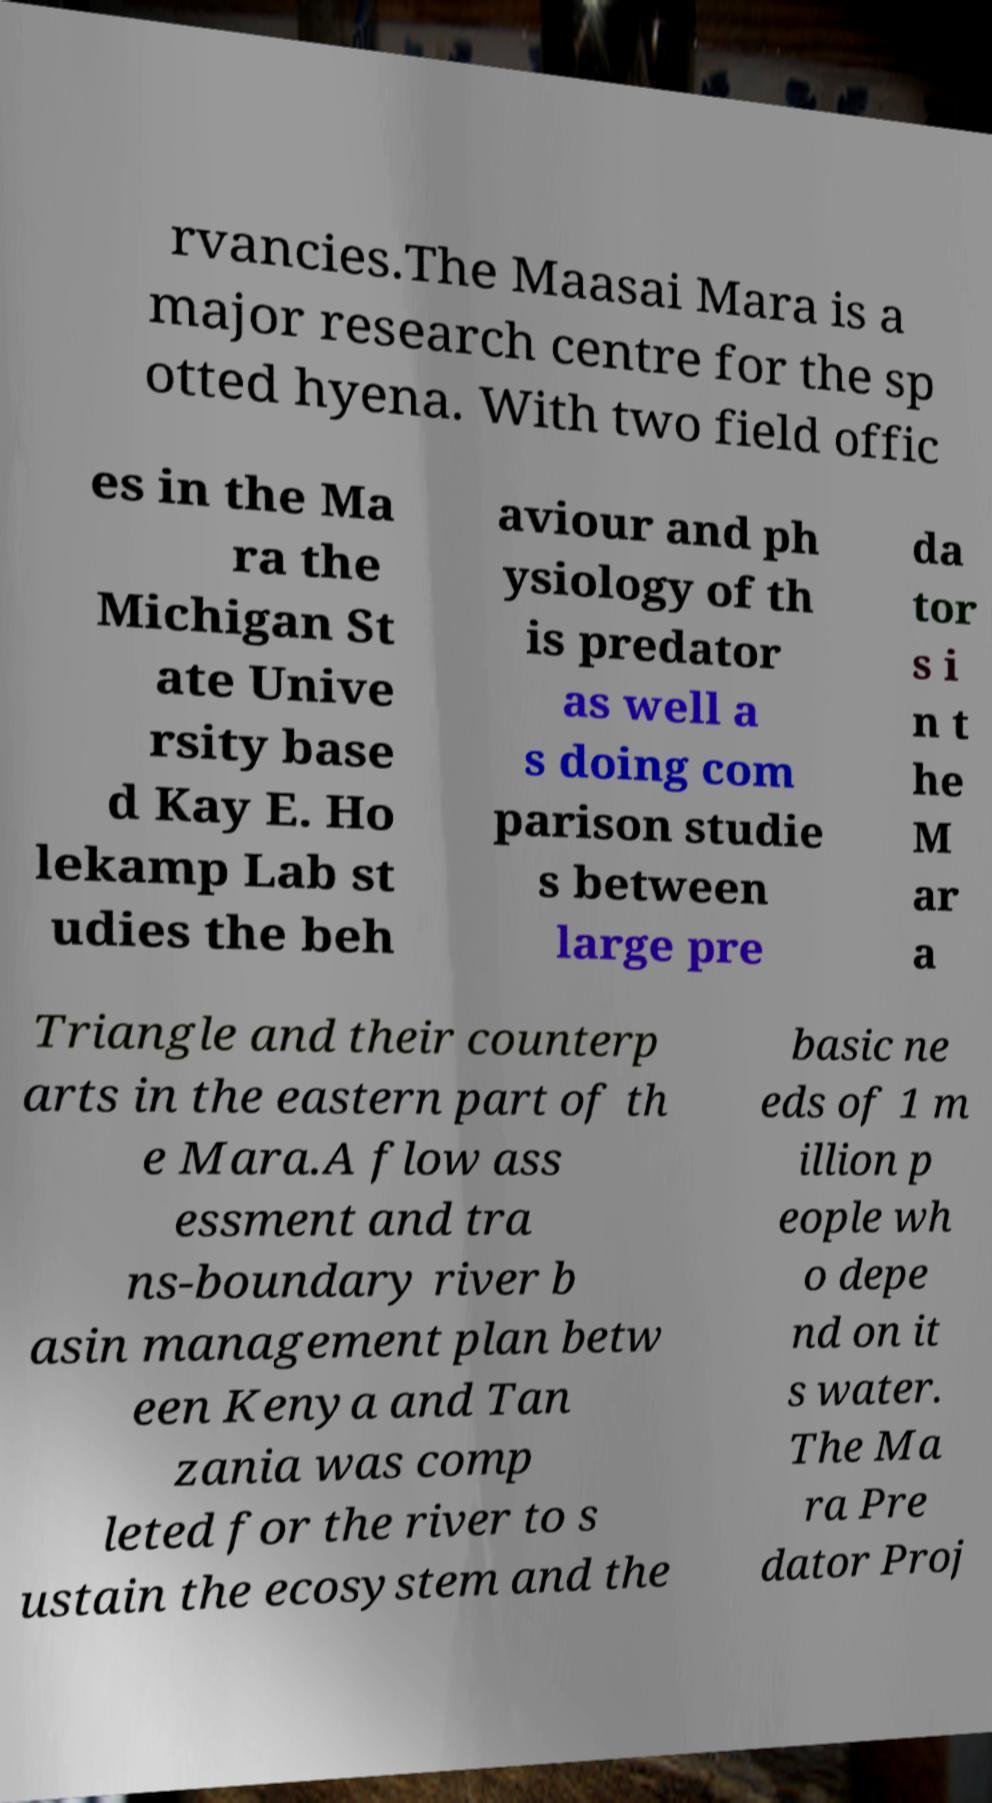Please identify and transcribe the text found in this image. rvancies.The Maasai Mara is a major research centre for the sp otted hyena. With two field offic es in the Ma ra the Michigan St ate Unive rsity base d Kay E. Ho lekamp Lab st udies the beh aviour and ph ysiology of th is predator as well a s doing com parison studie s between large pre da tor s i n t he M ar a Triangle and their counterp arts in the eastern part of th e Mara.A flow ass essment and tra ns-boundary river b asin management plan betw een Kenya and Tan zania was comp leted for the river to s ustain the ecosystem and the basic ne eds of 1 m illion p eople wh o depe nd on it s water. The Ma ra Pre dator Proj 